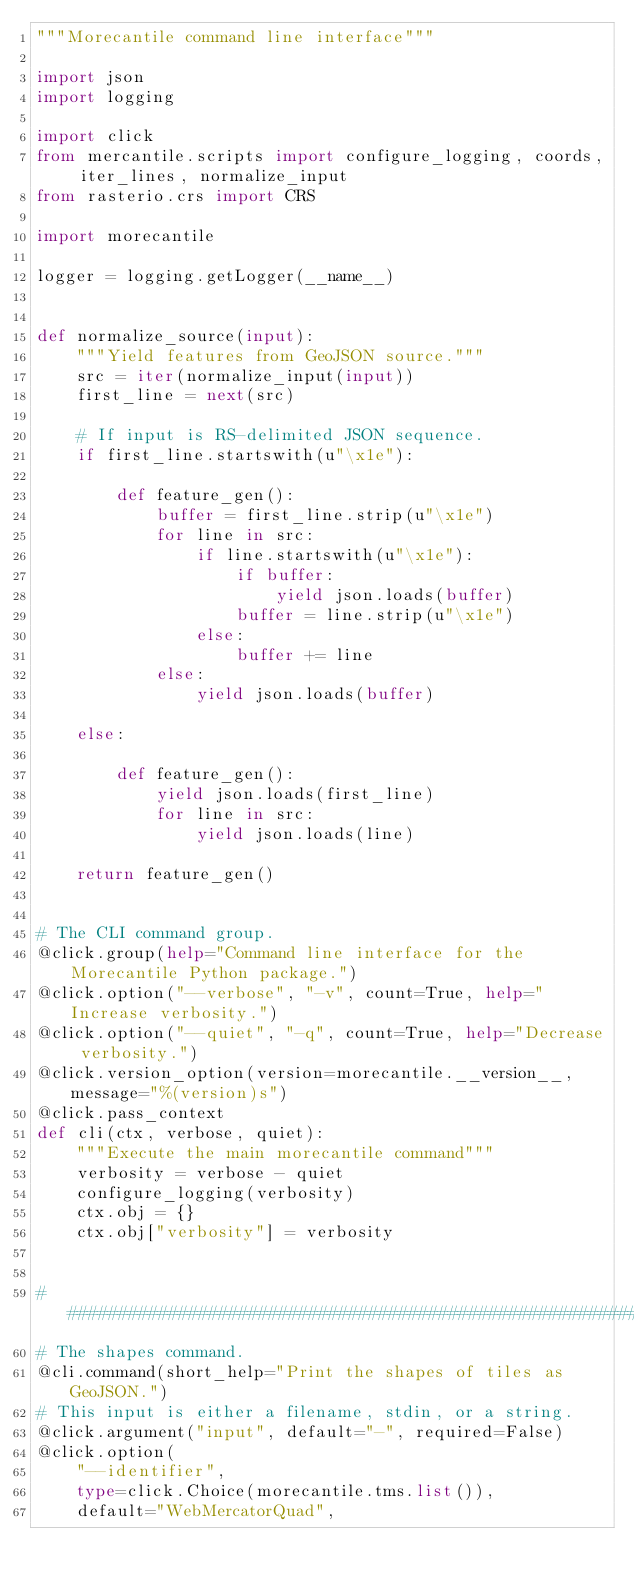<code> <loc_0><loc_0><loc_500><loc_500><_Python_>"""Morecantile command line interface"""

import json
import logging

import click
from mercantile.scripts import configure_logging, coords, iter_lines, normalize_input
from rasterio.crs import CRS

import morecantile

logger = logging.getLogger(__name__)


def normalize_source(input):
    """Yield features from GeoJSON source."""
    src = iter(normalize_input(input))
    first_line = next(src)

    # If input is RS-delimited JSON sequence.
    if first_line.startswith(u"\x1e"):

        def feature_gen():
            buffer = first_line.strip(u"\x1e")
            for line in src:
                if line.startswith(u"\x1e"):
                    if buffer:
                        yield json.loads(buffer)
                    buffer = line.strip(u"\x1e")
                else:
                    buffer += line
            else:
                yield json.loads(buffer)

    else:

        def feature_gen():
            yield json.loads(first_line)
            for line in src:
                yield json.loads(line)

    return feature_gen()


# The CLI command group.
@click.group(help="Command line interface for the Morecantile Python package.")
@click.option("--verbose", "-v", count=True, help="Increase verbosity.")
@click.option("--quiet", "-q", count=True, help="Decrease verbosity.")
@click.version_option(version=morecantile.__version__, message="%(version)s")
@click.pass_context
def cli(ctx, verbose, quiet):
    """Execute the main morecantile command"""
    verbosity = verbose - quiet
    configure_logging(verbosity)
    ctx.obj = {}
    ctx.obj["verbosity"] = verbosity


################################################################################
# The shapes command.
@cli.command(short_help="Print the shapes of tiles as GeoJSON.")
# This input is either a filename, stdin, or a string.
@click.argument("input", default="-", required=False)
@click.option(
    "--identifier",
    type=click.Choice(morecantile.tms.list()),
    default="WebMercatorQuad",</code> 